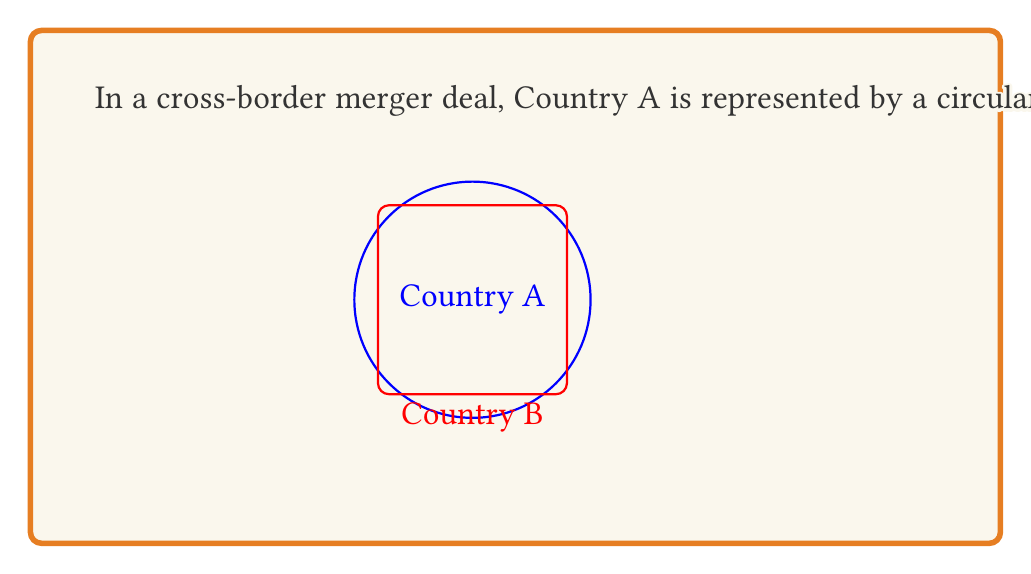Can you answer this question? To solve this problem, we need to follow these steps:

1. Calculate the area of Country A (circle):
   The formula for the area of a circle is $A = \pi r^2$
   $$A_A = \pi (100)^2 = 10000\pi \text{ km}^2$$

2. Calculate the area of Country B (square):
   The formula for the area of a square is $A = s^2$, where $s$ is the side length
   $$A_B = 160^2 = 25600 \text{ km}^2$$

3. Calculate the ratio of Country B's area to Country A's area:
   $$\text{Ratio} = \frac{A_B}{A_A} = \frac{25600}{10000\pi}$$

4. Simplify the ratio:
   $$\frac{25600}{10000\pi} = \frac{256}{100\pi} = \frac{64}{25\pi}$$

Thus, the ratio of Country B's area to Country A's area is $\frac{64}{25\pi}$.
Answer: $\frac{64}{25\pi}$ 